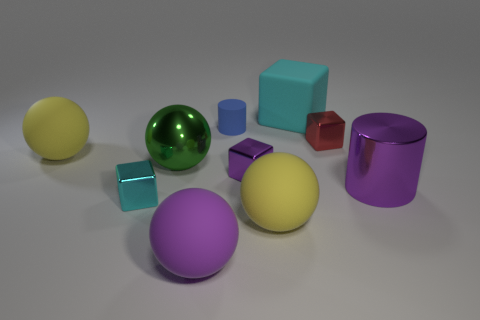Subtract all green spheres. How many spheres are left? 3 Subtract all purple cylinders. How many cylinders are left? 1 Subtract 2 spheres. How many spheres are left? 2 Subtract all gray cubes. How many purple cylinders are left? 1 Subtract all cyan balls. Subtract all tiny cyan shiny objects. How many objects are left? 9 Add 2 big balls. How many big balls are left? 6 Add 5 big cyan cubes. How many big cyan cubes exist? 6 Subtract 0 green blocks. How many objects are left? 10 Subtract all cubes. How many objects are left? 6 Subtract all green blocks. Subtract all blue spheres. How many blocks are left? 4 